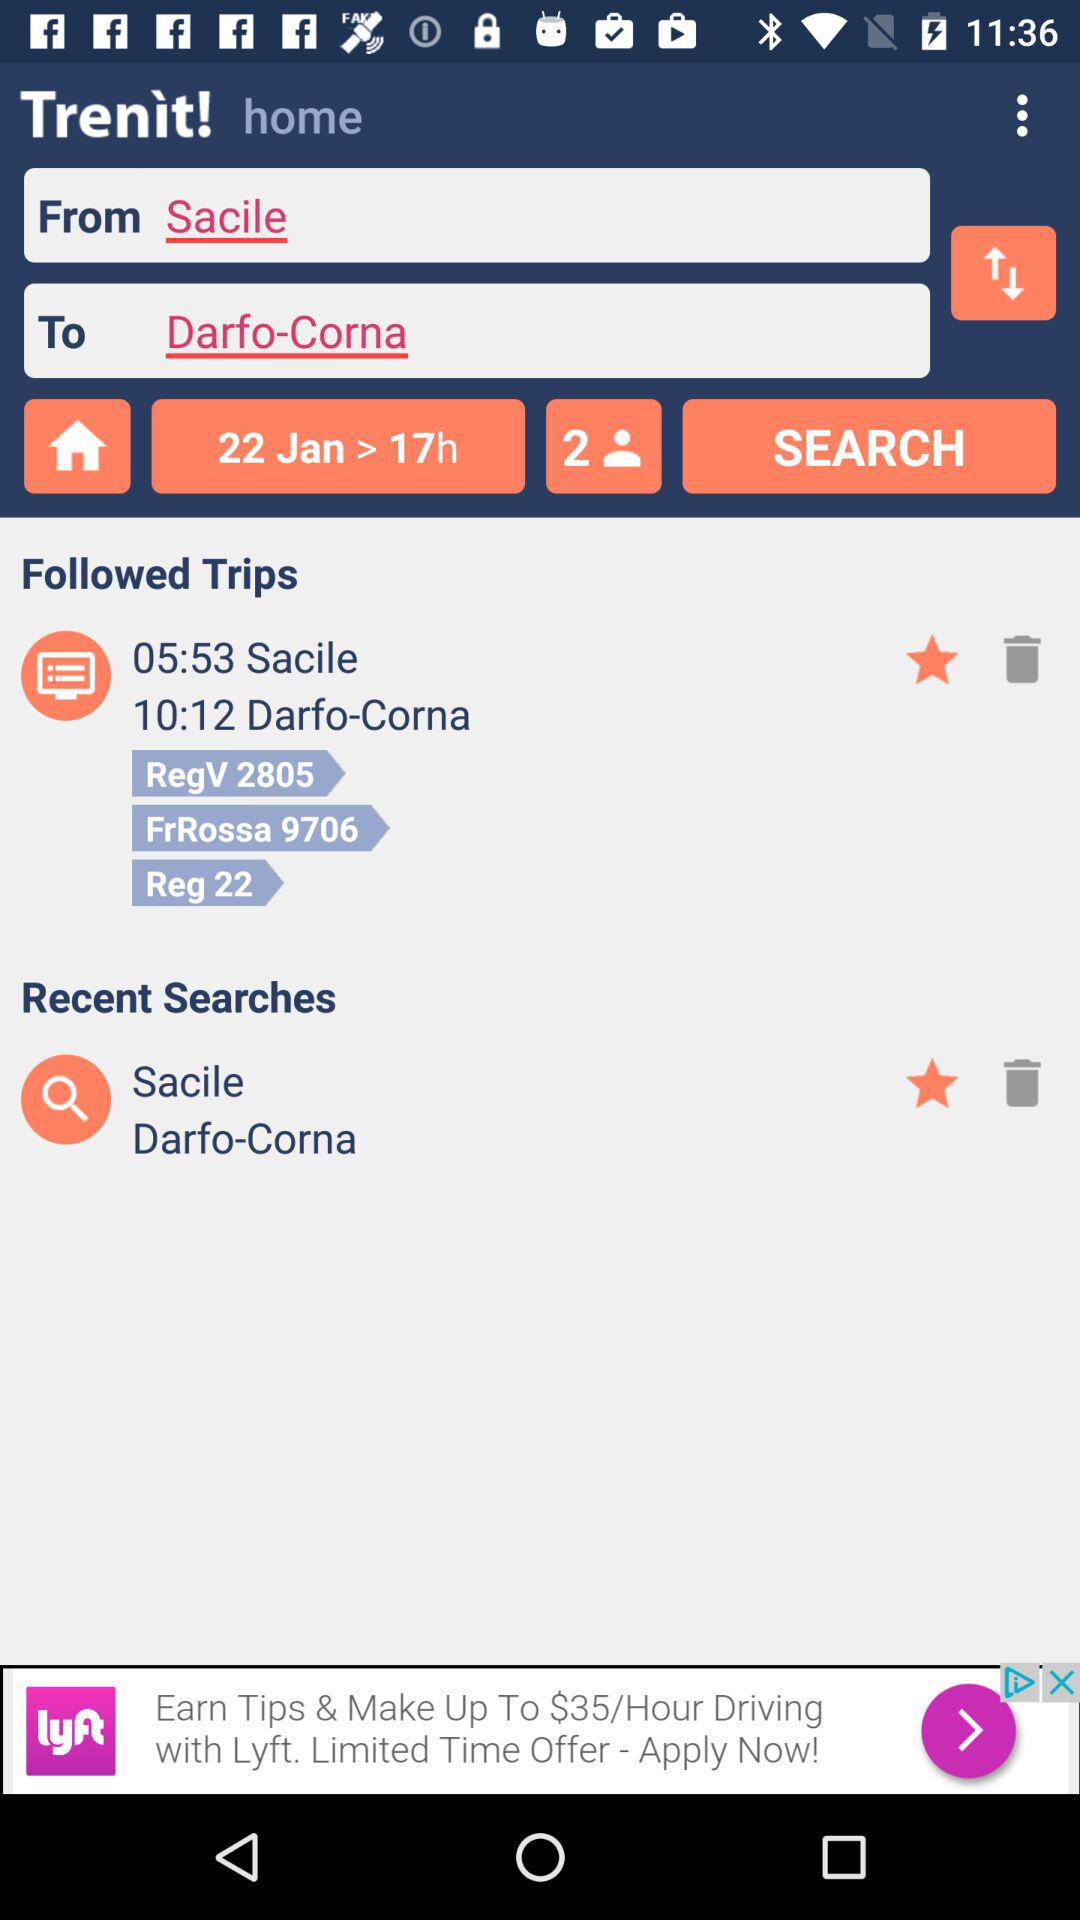Which date is selected? The selected date is January 22. 